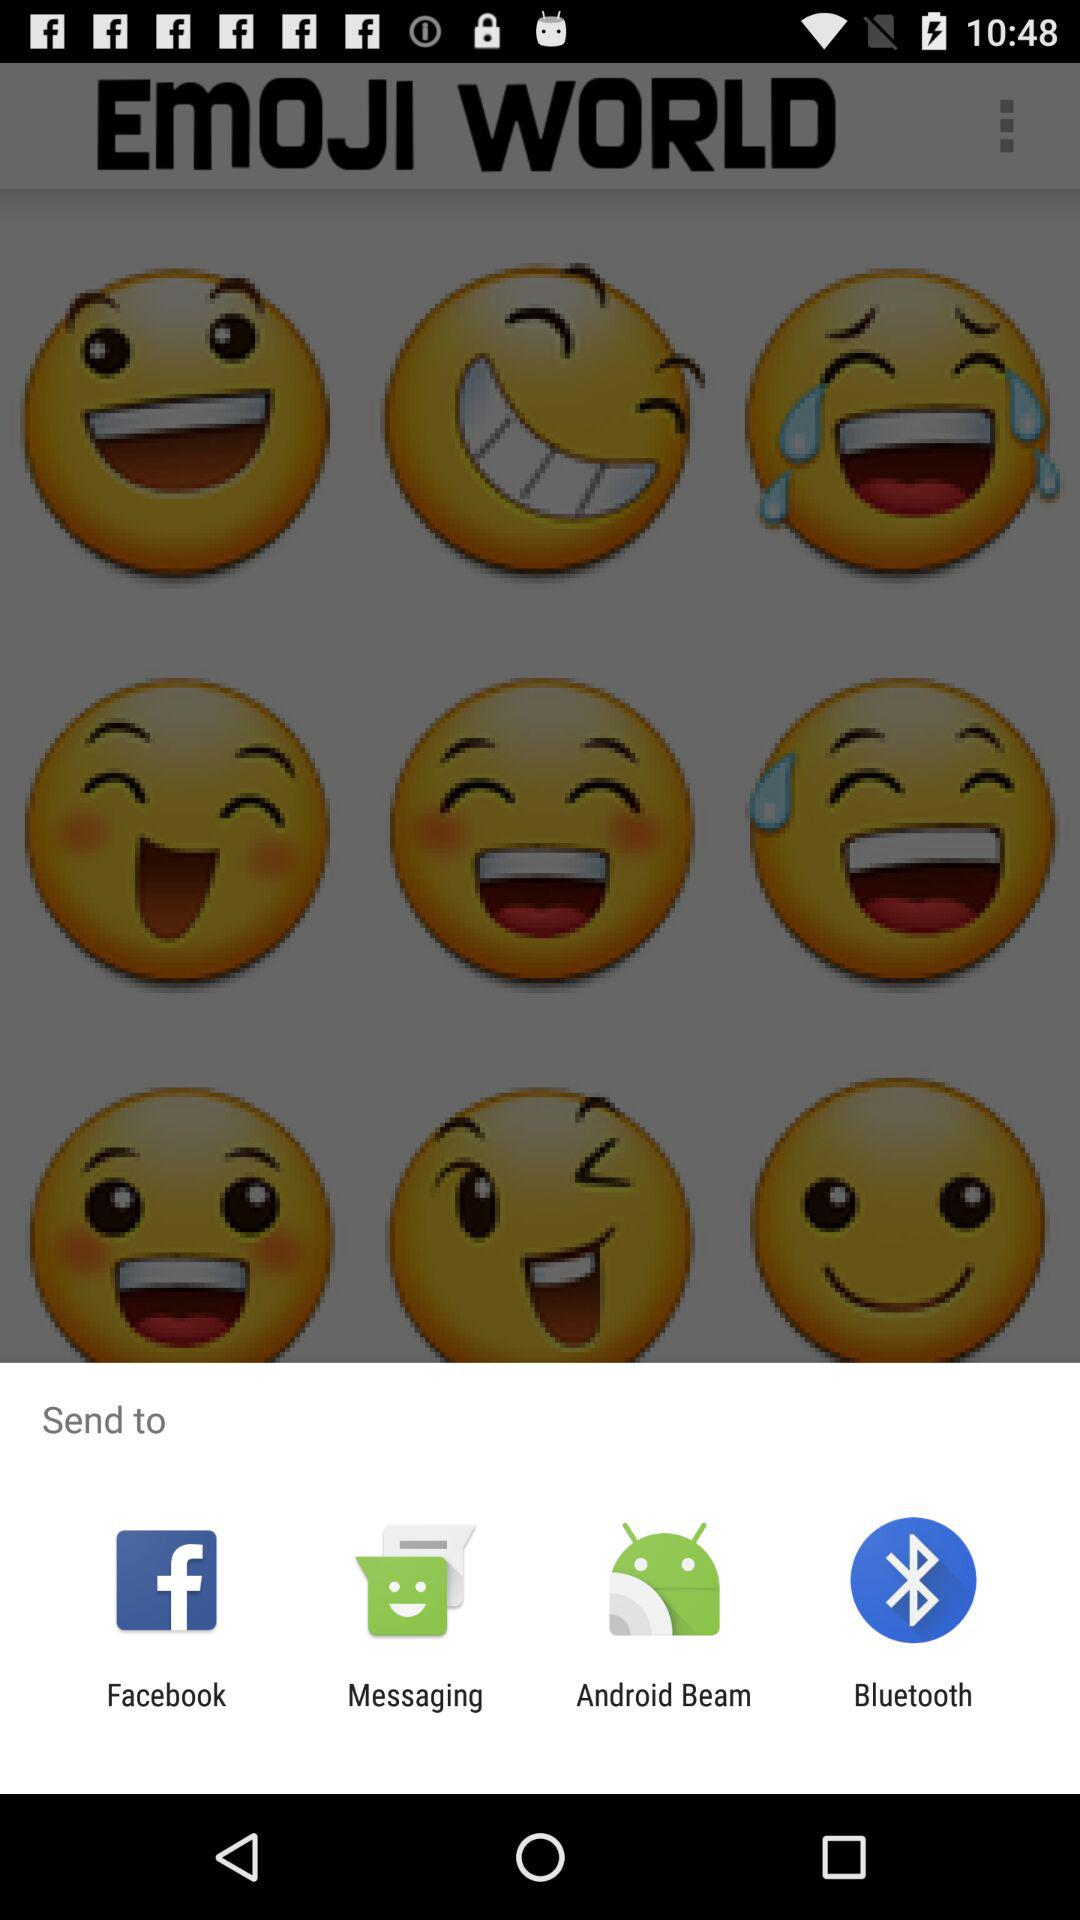What are the apps that can be used to send the content? The apps that can be used to send the content are "Facebook", "Messaging", "Android Beam" and "Bluetooth". 